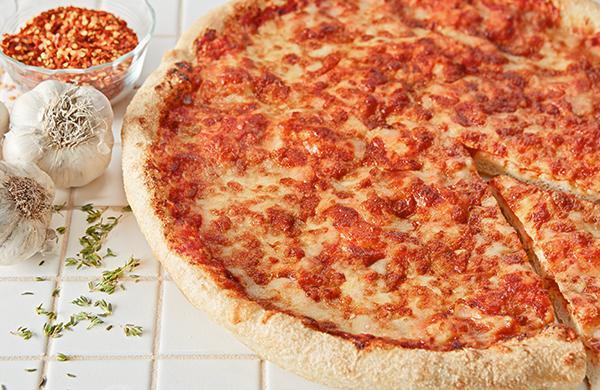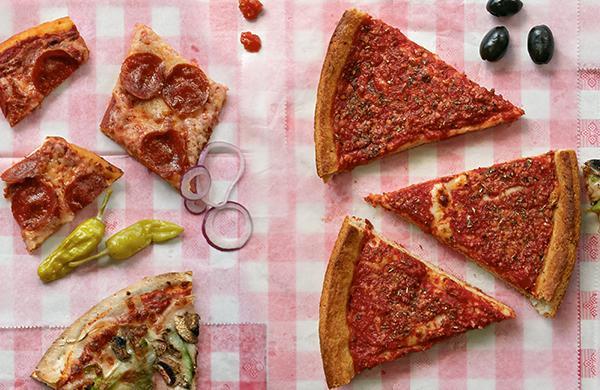The first image is the image on the left, the second image is the image on the right. Given the left and right images, does the statement "In one of the images the pizza is cut into squares." hold true? Answer yes or no. No. The first image is the image on the left, the second image is the image on the right. Examine the images to the left and right. Is the description "One image shows a round pizza cut in triangular 'pie' slices, with a slice at least partly off, and the other image features a pizza cut in squares." accurate? Answer yes or no. No. 